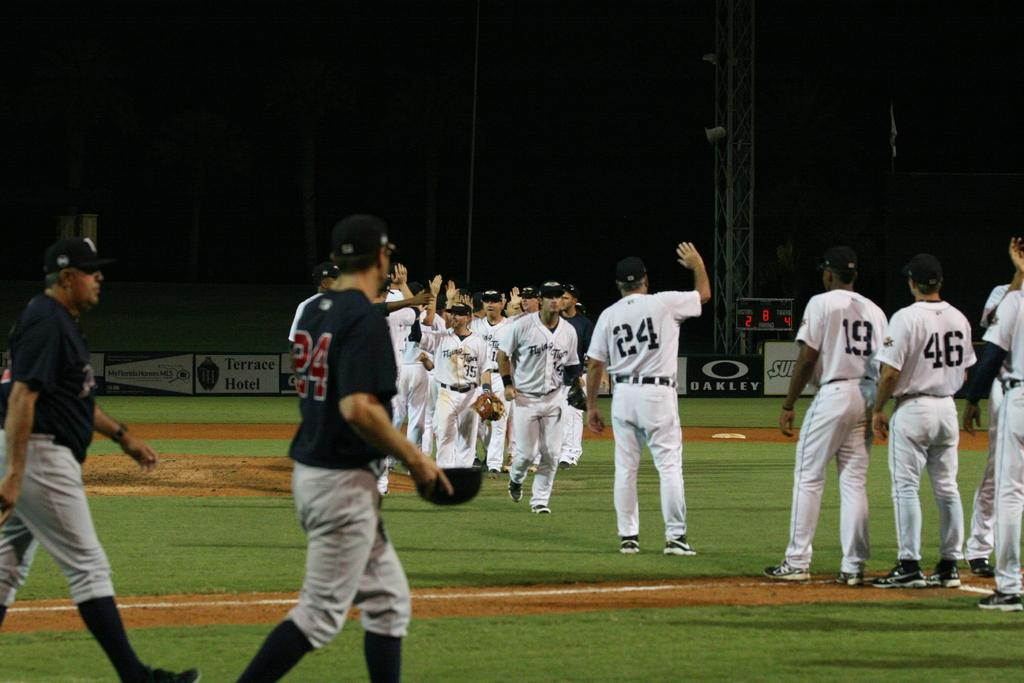<image>
Render a clear and concise summary of the photo. Player number 24 has his right arm up in the air as he waves to someone. 